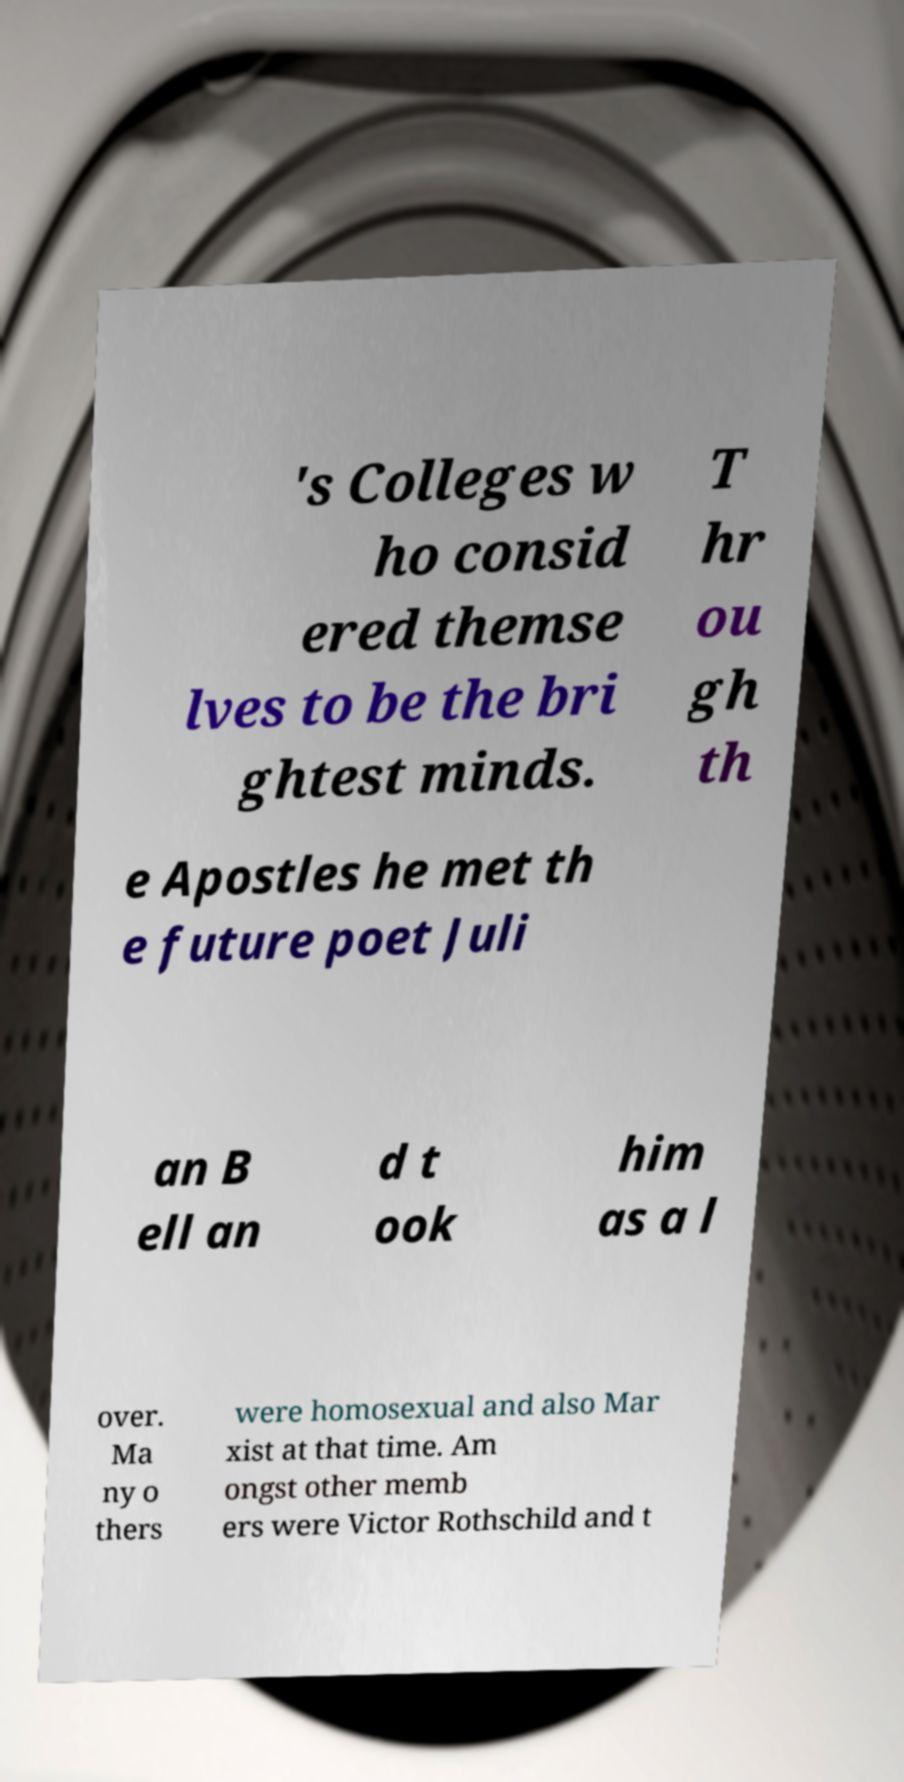There's text embedded in this image that I need extracted. Can you transcribe it verbatim? 's Colleges w ho consid ered themse lves to be the bri ghtest minds. T hr ou gh th e Apostles he met th e future poet Juli an B ell an d t ook him as a l over. Ma ny o thers were homosexual and also Mar xist at that time. Am ongst other memb ers were Victor Rothschild and t 